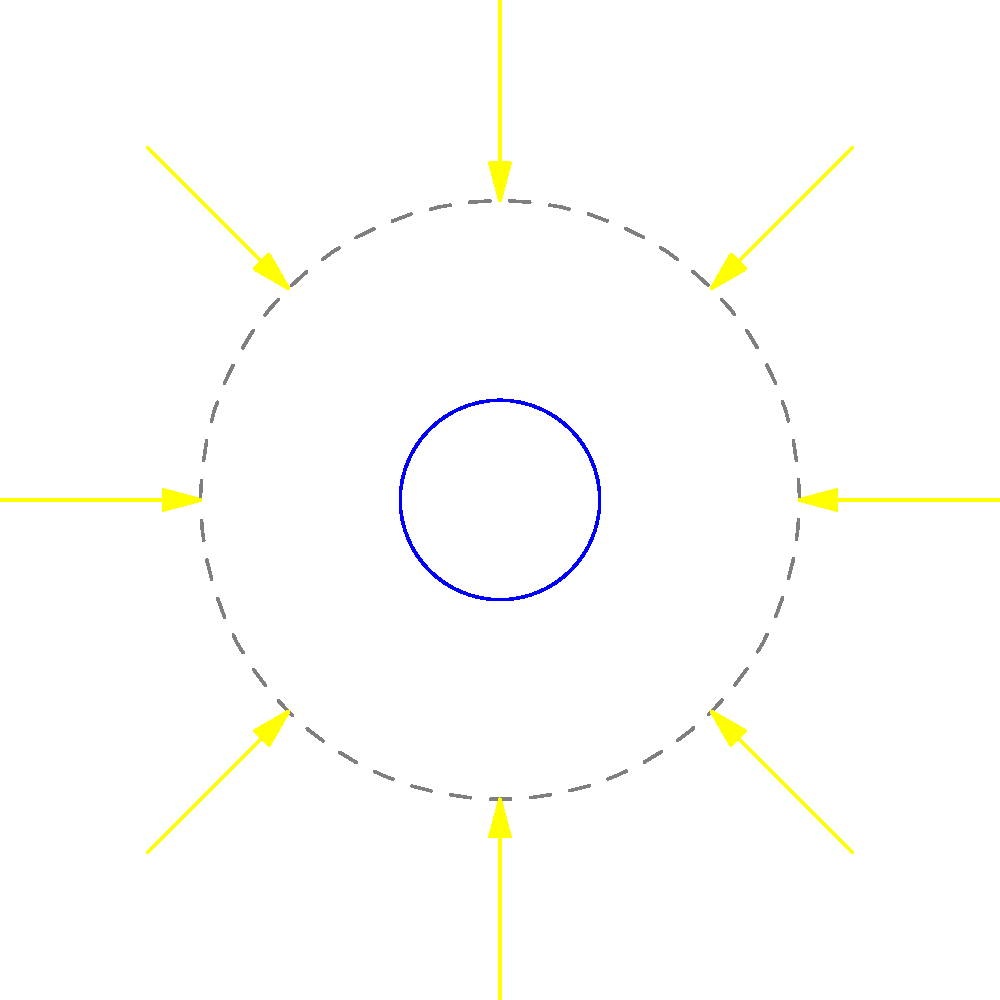The diagram shows the Earth, Moon, and direction of sunlight. Which position of the Moon corresponds to the New Moon phase as seen from Earth? To determine the New Moon phase, we need to understand the following steps:

1. The New Moon occurs when the Moon is between the Earth and the Sun.
2. During this phase, the side of the Moon facing Earth is not illuminated by the Sun.
3. In the diagram:
   - The blue circle represents Earth.
   - The gray dashed circle represents the Moon's orbit.
   - The yellow arrows indicate the direction of sunlight.
   - The gray circles labeled A, B, C, and D represent different positions of the Moon.

4. Analyzing each position:
   - Position A: Moon is to the right of Earth, partially illuminated.
   - Position B: Moon is above Earth, half illuminated.
   - Position C: Moon is to the left of Earth, between Earth and Sun.
   - Position D: Moon is below Earth, half illuminated.

5. The New Moon phase occurs when the Moon is directly between the Earth and the Sun.

Therefore, position C corresponds to the New Moon phase, as it is the only position where the Moon is directly between the Earth and the Sun.
Answer: C 